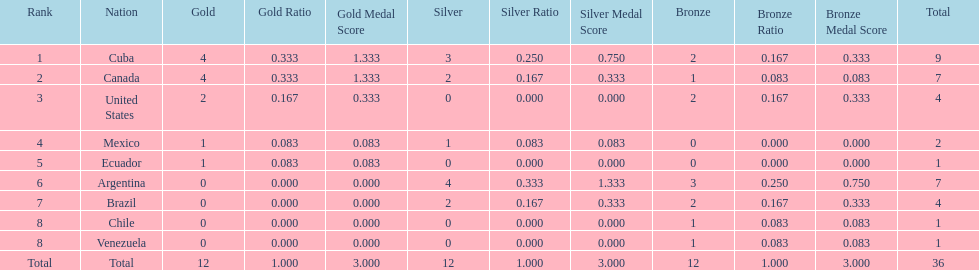How many total medals were there all together? 36. 